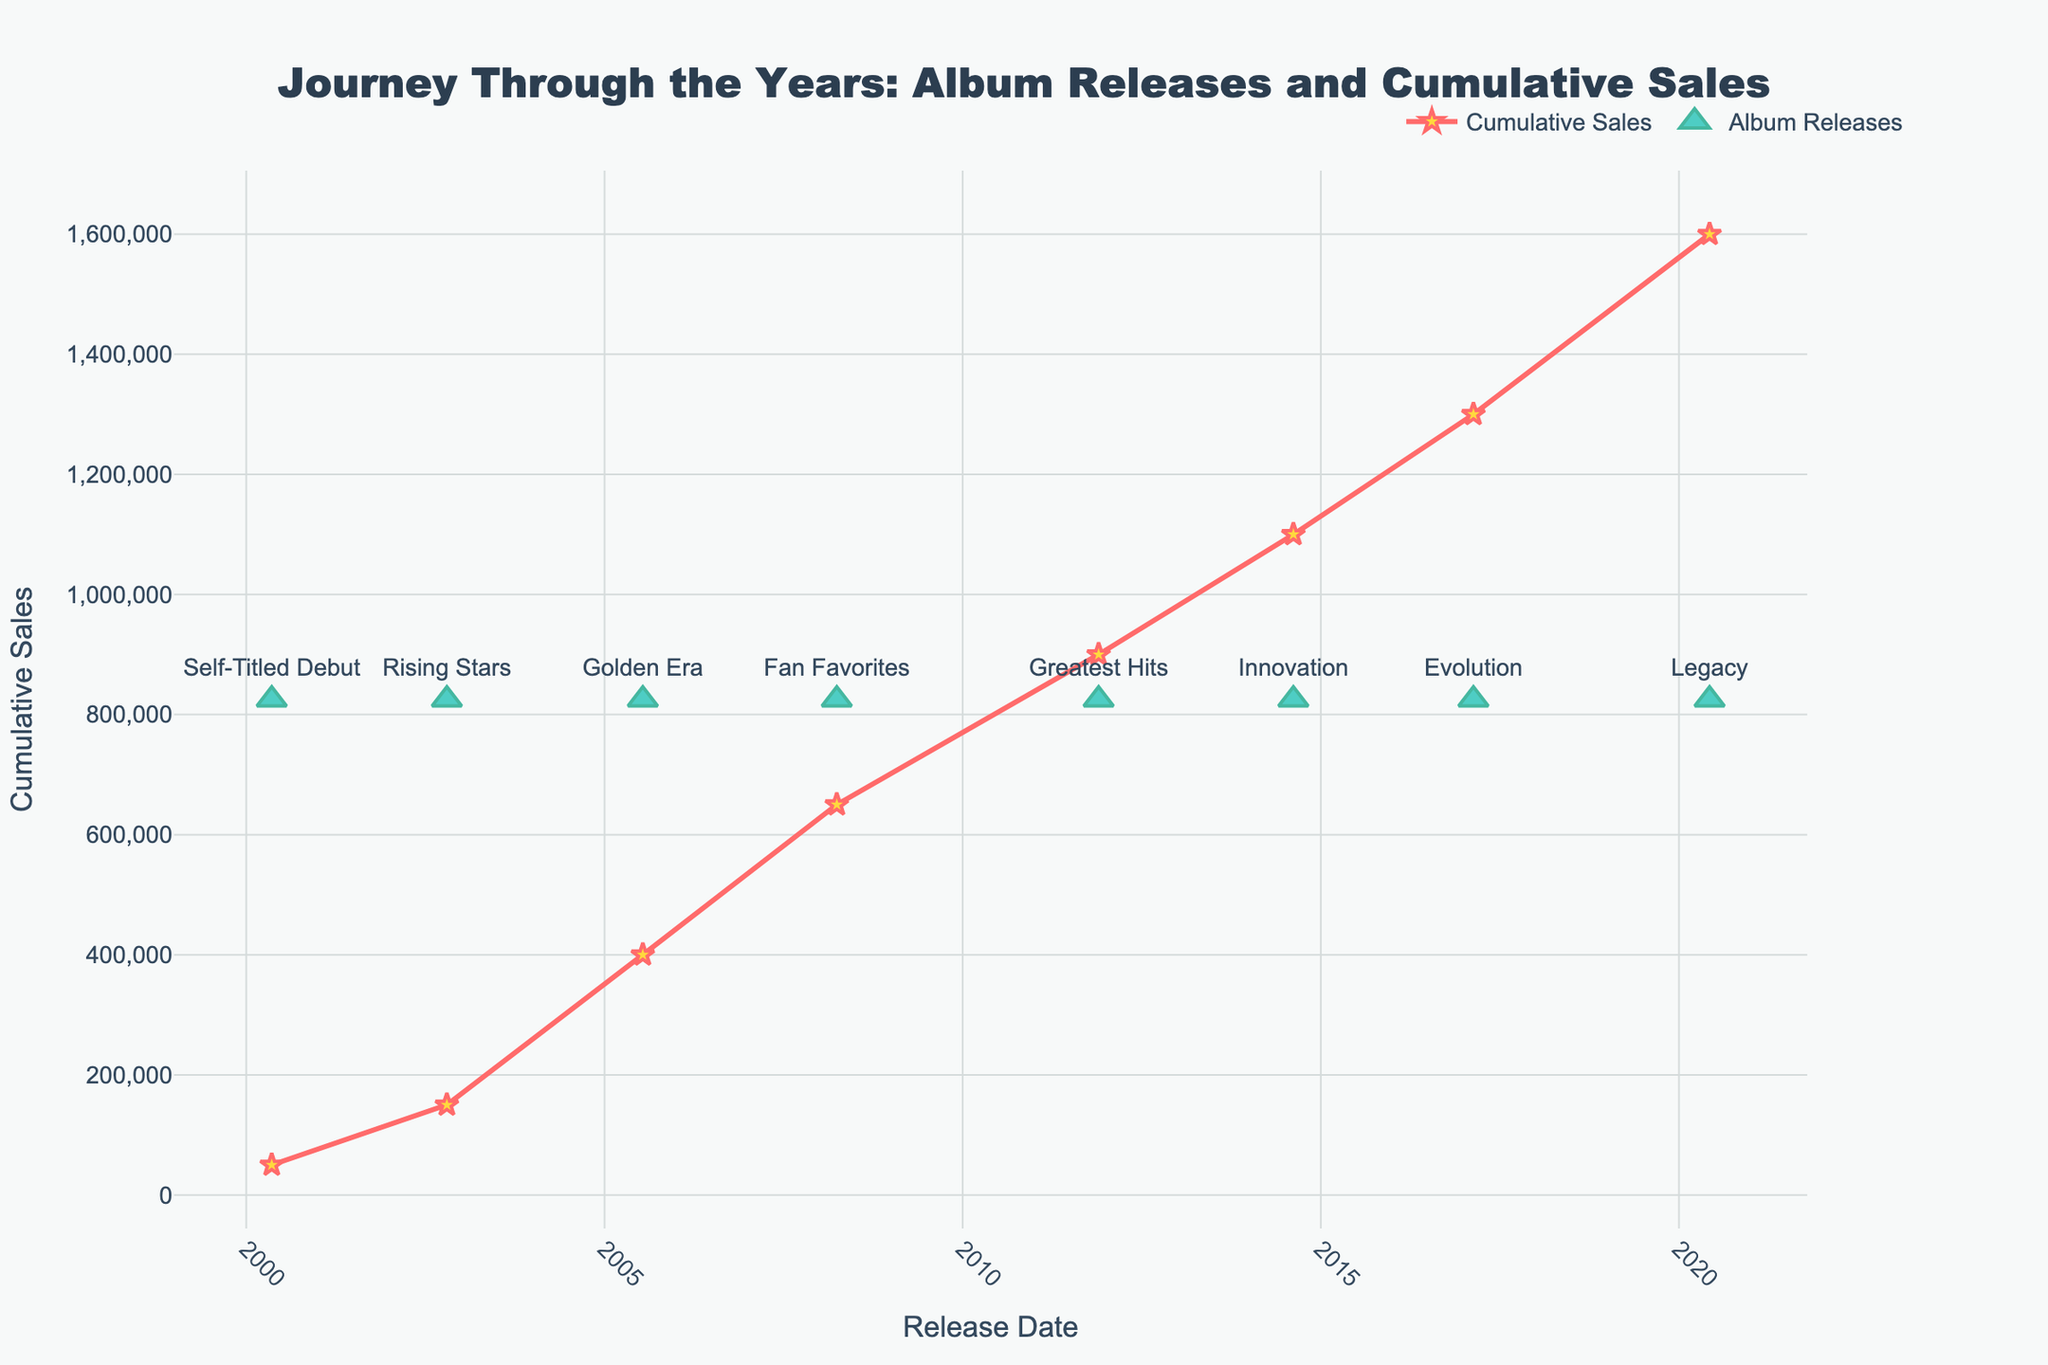What's the title of the plot? The title is located at the top of the plot, usually in a larger and bold font for prominence. Here, it reads "Journey Through the Years: Album Releases and Cumulative Sales."
Answer: Journey Through the Years: Album Releases and Cumulative Sales How many albums are represented in the plot? To determine the number of albums, count the distinct markers or points labeled with album names along the bottom of the plot.
Answer: 8 What color are the cumulative sales lines and markers? The cumulative sales line is represented by a line with specific markers. The lines are in red, and the markers (stars) are yellow.
Answer: Red and Yellow Which album had the highest cumulative sales and what was the amount? Find the album release data point where the cumulative sales line reaches its highest point. The highest point in the plot is for the album "Legacy," with cumulative sales at 1,600,000.
Answer: Legacy, 1,600,000 What is the cumulative sales after the release of "Golden Era"? Look for the data point associated with "Golden Era" on the timeline and read the corresponding cumulative sales value from the y-axis.
Answer: 400,000 What is the time gap between the release of "Fan Favorites" and "Greatest Hits"? Identify the release dates of both albums and subtract the earlier date from the later date to determine the duration. "Fan Favorites" was released on March 30, 2008, and "Greatest Hits" on November 25, 2011.
Answer: 3 years and 8 months Which album has the smallest increase in cumulative sales compared to its predecessor? Examine the cumulative sales values and compare the increases between consecutive albums. The smallest increase is from "Evolution" to "Legacy," as it went from 1,300,000 to 1,600,000 (an increase of 300,000).
Answer: Evolution to Legacy How many years did it take to reach 1,100,000 cumulative sales? Track the first point where the cumulative sales line reaches or exceeds 1,100,000, which happens after "Innovation" was released on August 14, 2014. The starting year was 2000, so it took 14 years.
Answer: 14 years What is the average cumulative sales value of all albums? Sum the cumulative sales values of all albums and divide it by the total number of albums. The sum is 7,450,000 for 8 albums, resulting in an average of 7,450,000 / 8.
Answer: 931,250 